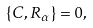Convert formula to latex. <formula><loc_0><loc_0><loc_500><loc_500>\{ C , R _ { \alpha } \} = 0 ,</formula> 